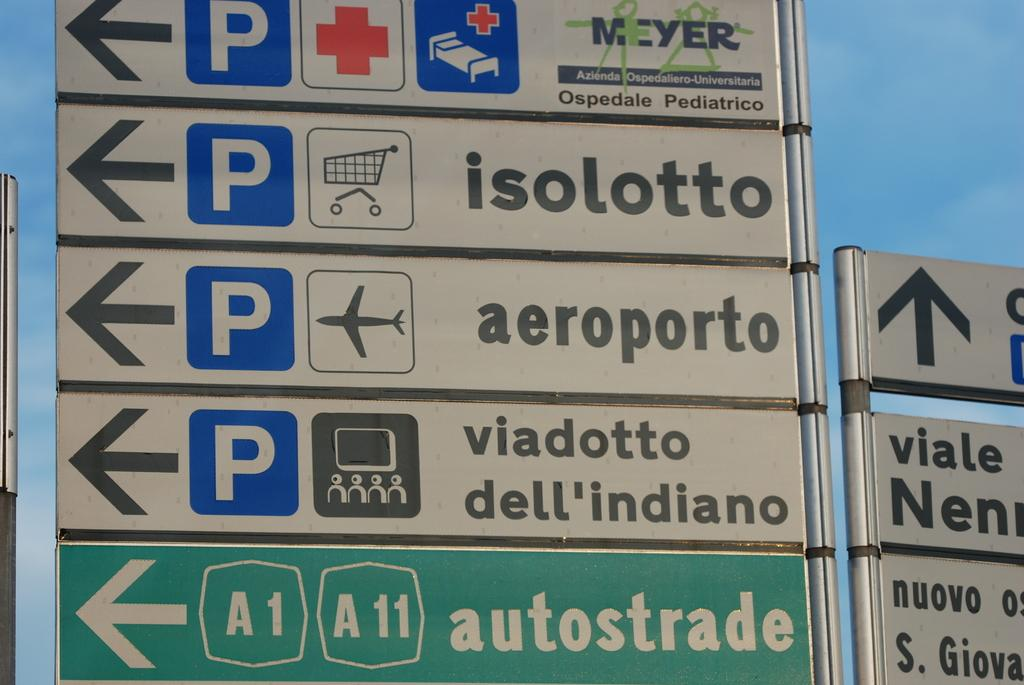Provide a one-sentence caption for the provided image. A sign points to different locations, including an airport and a supermarket. 